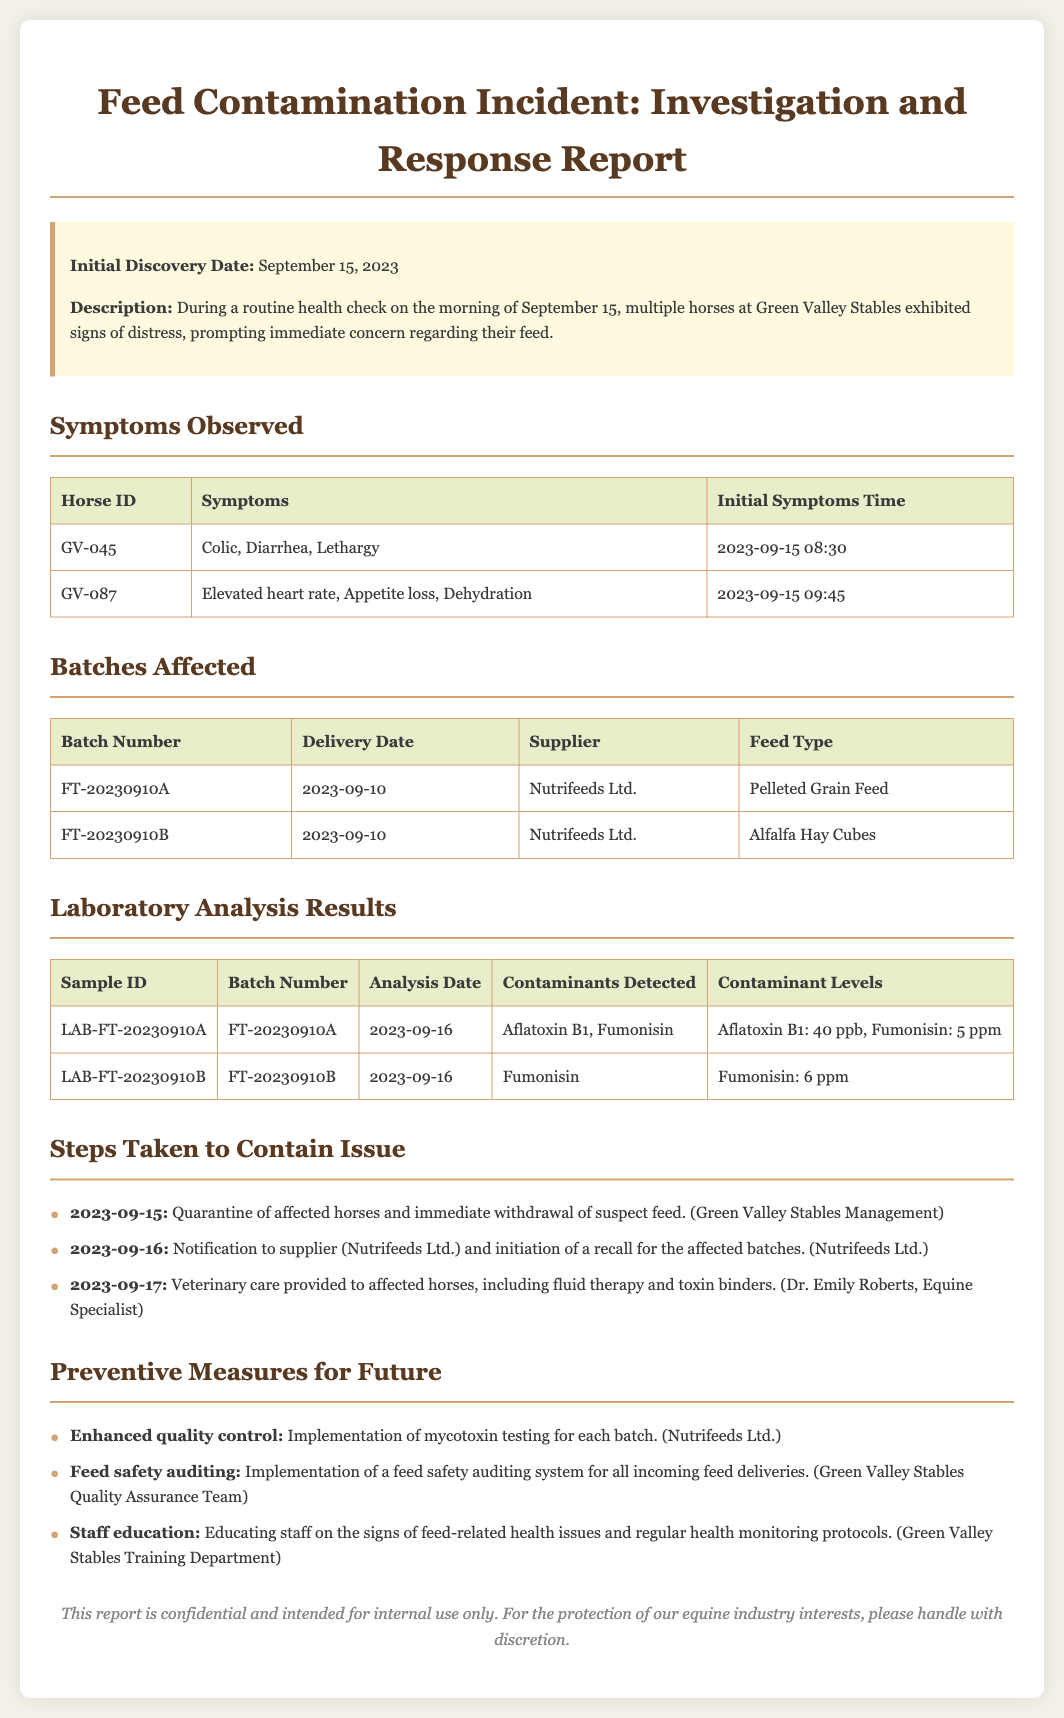What is the initial discovery date? The initial discovery date is provided in the incident report as the date when the symptoms were first noted in the horses.
Answer: September 15, 2023 How many horses showed symptoms? The report mentions multiple horses exhibiting signs of distress, specifically detailing symptoms for two horses.
Answer: 2 What was the contaminant level of Aflatoxin B1? The report includes laboratory analysis results, specifying the levels of contaminants detected in the affected batches.
Answer: 40 ppb Which supplier provided the affected feed? The incident report lists the supplier that delivered the contaminated feed batches, which is essential for accountability and recall procedures.
Answer: Nutrifeeds Ltd What type of feed was affected in batch FT-20230910B? The report details the type of feed linked to the affected batches, which can help identify the source of contamination.
Answer: Alfalfa Hay Cubes What steps were taken on September 16? The timeline of steps taken to address the issue includes actions by both the management and the supplier, showing the response efforts.
Answer: Notification to supplier and initiation of a recall What preventive measure involves staff education? The report outlines future preventive measures that include education programs for staff to help prevent similar incidents.
Answer: Educating staff on the signs of feed-related health issues 